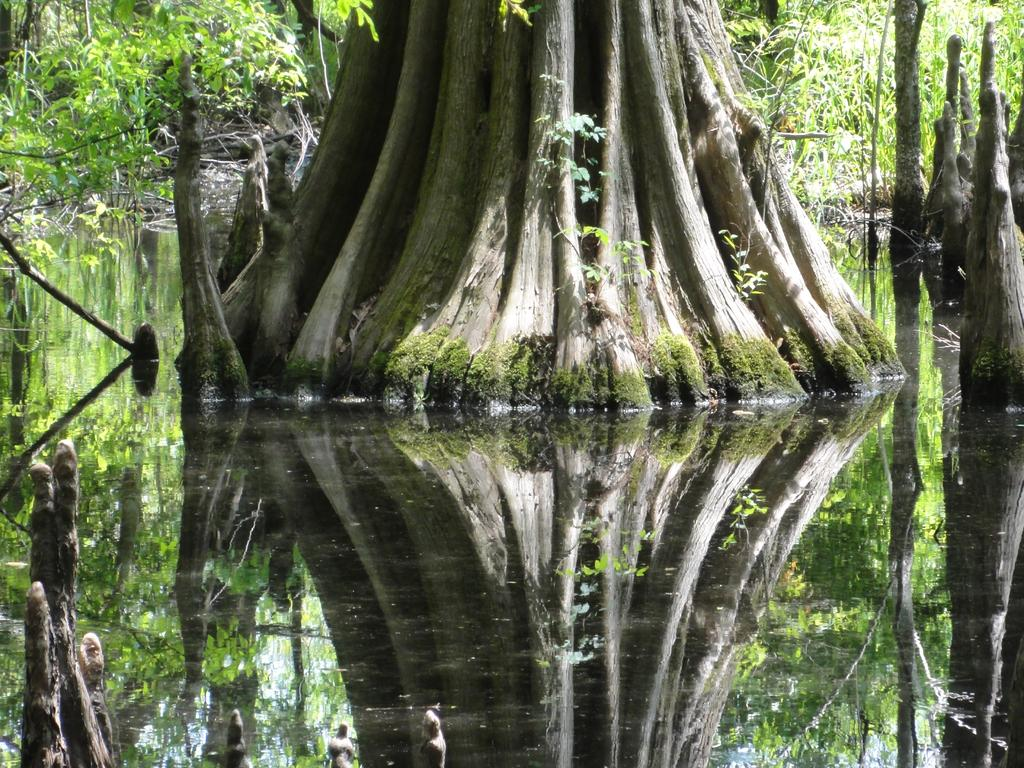What type of natural structures can be seen in the image? There are tree trunks and trees visible in the image. What else can be seen in the image besides the tree trunks and trees? There is water and plants visible in the image. What objects made of wood can be seen in the image? There are wooden sticks in the image. What type of meal is being prepared in the image? There is no meal preparation visible in the image. What is the size of the trees in the image? The size of the trees cannot be determined from the image alone, as there is no reference point for comparison. 